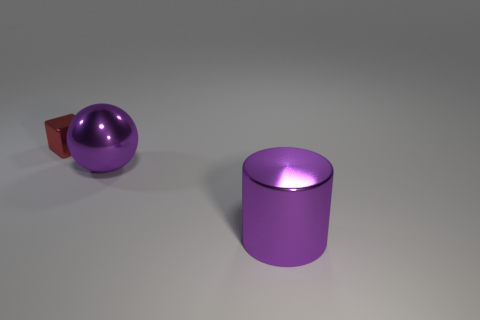Subtract all cubes. How many objects are left? 2 Add 1 large red rubber cylinders. How many objects exist? 4 Subtract all brown cylinders. Subtract all cyan balls. How many cylinders are left? 1 Subtract all tiny yellow metallic spheres. Subtract all red metal things. How many objects are left? 2 Add 1 big purple metallic cylinders. How many big purple metallic cylinders are left? 2 Add 3 purple metal objects. How many purple metal objects exist? 5 Subtract 1 purple cylinders. How many objects are left? 2 Subtract 1 cylinders. How many cylinders are left? 0 